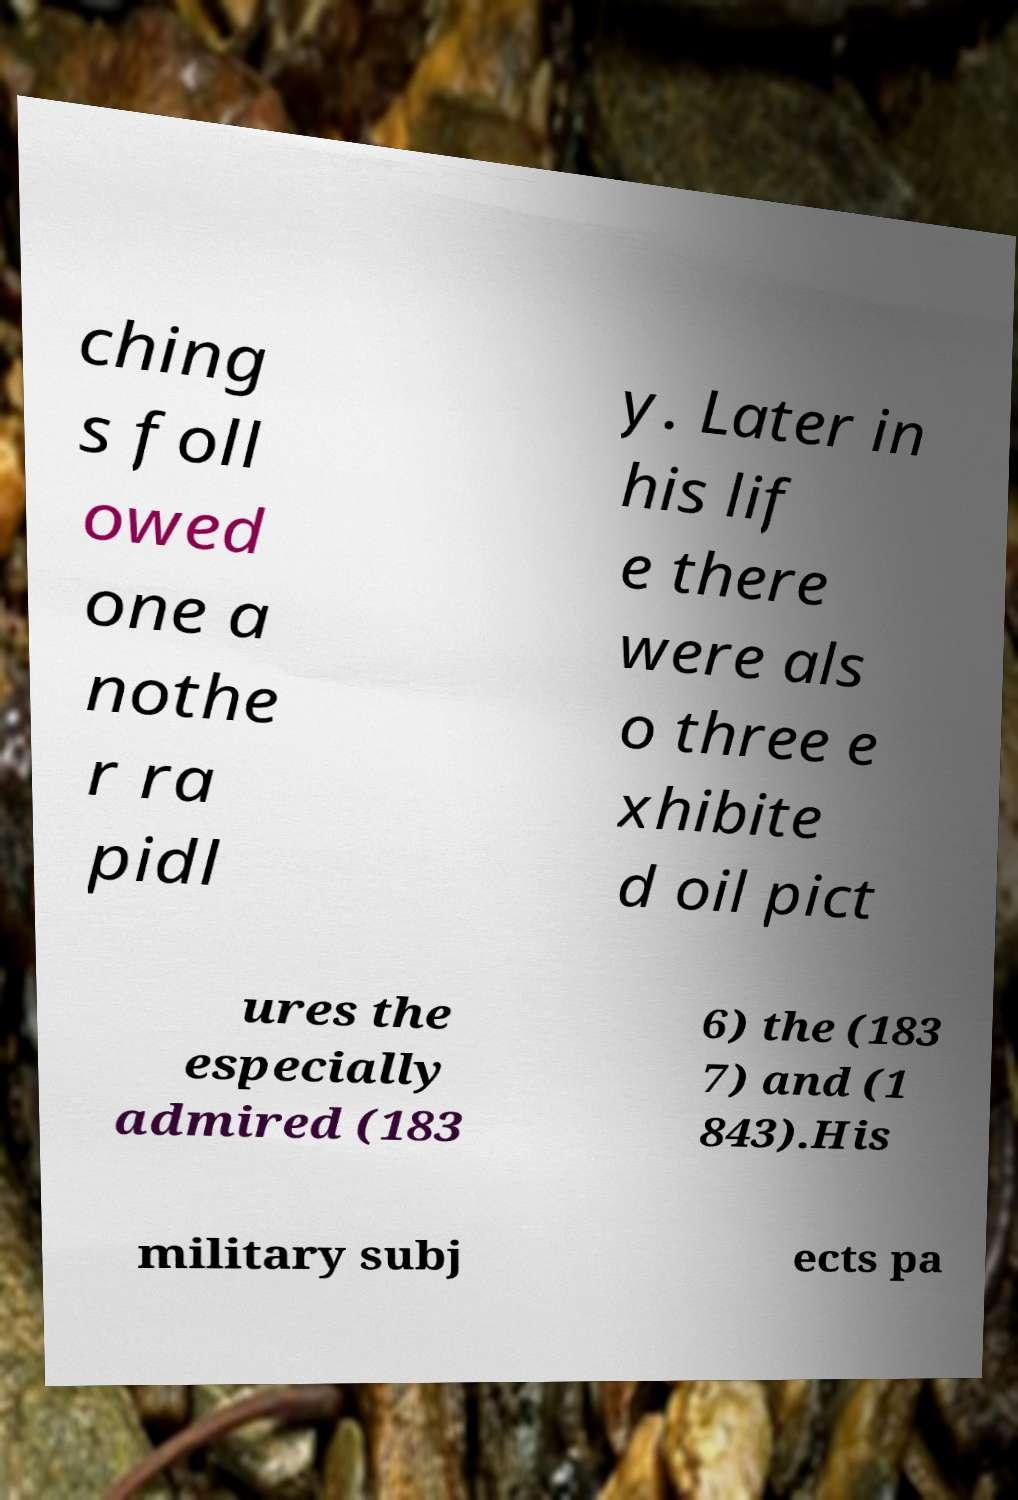Could you extract and type out the text from this image? ching s foll owed one a nothe r ra pidl y. Later in his lif e there were als o three e xhibite d oil pict ures the especially admired (183 6) the (183 7) and (1 843).His military subj ects pa 